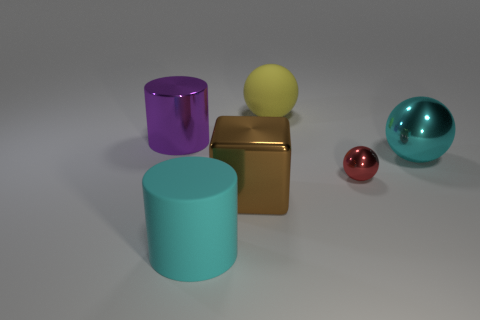What time of day does the lighting in the scene suggest? The lighting in the image does not strongly suggest a specific time of day because it appears to be an indoor setting with controlled, artificial lighting. The shadows are soft and there's an overall even illumination, which is typical for studio lighting setups. 